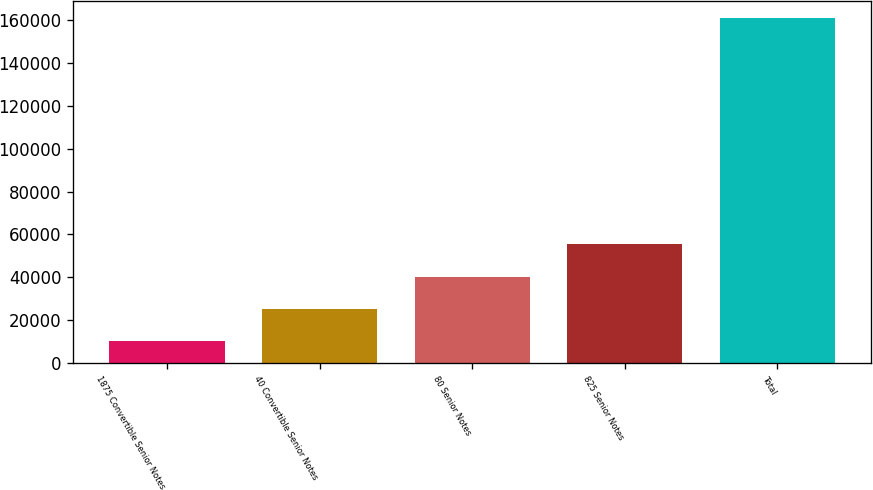<chart> <loc_0><loc_0><loc_500><loc_500><bar_chart><fcel>1875 Convertible Senior Notes<fcel>40 Convertible Senior Notes<fcel>80 Senior Notes<fcel>825 Senior Notes<fcel>Total<nl><fcel>10090<fcel>25170.6<fcel>40251.2<fcel>55331.8<fcel>160896<nl></chart> 